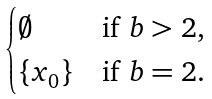Convert formula to latex. <formula><loc_0><loc_0><loc_500><loc_500>\begin{cases} \emptyset & \text {if $b > 2,$} \\ \{ x _ { 0 } \} & \text {if $b=2.$} \end{cases}</formula> 